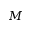<formula> <loc_0><loc_0><loc_500><loc_500>M</formula> 